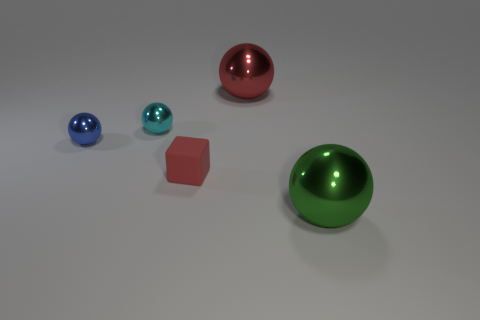Are there any green balls made of the same material as the cyan sphere?
Your answer should be very brief. Yes. What is the large sphere that is on the left side of the big metal object in front of the cyan metallic ball made of?
Ensure brevity in your answer.  Metal. How big is the red object on the left side of the red ball?
Make the answer very short. Small. Does the tiny matte block have the same color as the sphere that is in front of the tiny rubber thing?
Provide a succinct answer. No. Is there another block of the same color as the small block?
Keep it short and to the point. No. Are the block and the large ball that is behind the large green metal thing made of the same material?
Give a very brief answer. No. How many large things are red metal objects or shiny balls?
Offer a very short reply. 2. There is a big sphere that is the same color as the matte block; what is its material?
Ensure brevity in your answer.  Metal. Are there fewer blocks than large cyan shiny balls?
Give a very brief answer. No. There is a red shiny object left of the green thing; is its size the same as the ball in front of the blue sphere?
Your answer should be compact. Yes. 